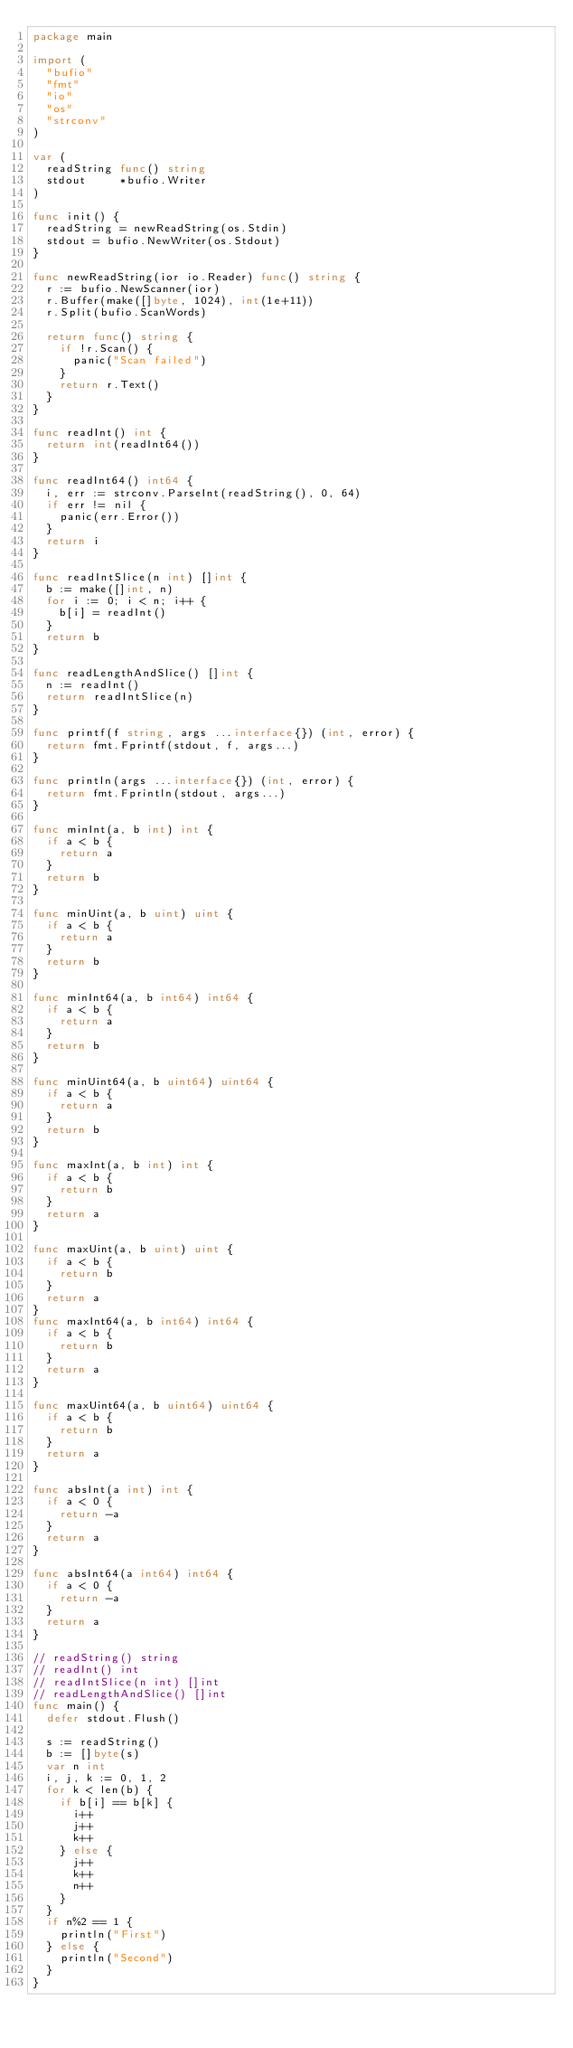<code> <loc_0><loc_0><loc_500><loc_500><_Go_>package main

import (
	"bufio"
	"fmt"
	"io"
	"os"
	"strconv"
)

var (
	readString func() string
	stdout     *bufio.Writer
)

func init() {
	readString = newReadString(os.Stdin)
	stdout = bufio.NewWriter(os.Stdout)
}

func newReadString(ior io.Reader) func() string {
	r := bufio.NewScanner(ior)
	r.Buffer(make([]byte, 1024), int(1e+11))
	r.Split(bufio.ScanWords)

	return func() string {
		if !r.Scan() {
			panic("Scan failed")
		}
		return r.Text()
	}
}

func readInt() int {
	return int(readInt64())
}

func readInt64() int64 {
	i, err := strconv.ParseInt(readString(), 0, 64)
	if err != nil {
		panic(err.Error())
	}
	return i
}

func readIntSlice(n int) []int {
	b := make([]int, n)
	for i := 0; i < n; i++ {
		b[i] = readInt()
	}
	return b
}

func readLengthAndSlice() []int {
	n := readInt()
	return readIntSlice(n)
}

func printf(f string, args ...interface{}) (int, error) {
	return fmt.Fprintf(stdout, f, args...)
}

func println(args ...interface{}) (int, error) {
	return fmt.Fprintln(stdout, args...)
}

func minInt(a, b int) int {
	if a < b {
		return a
	}
	return b
}

func minUint(a, b uint) uint {
	if a < b {
		return a
	}
	return b
}

func minInt64(a, b int64) int64 {
	if a < b {
		return a
	}
	return b
}

func minUint64(a, b uint64) uint64 {
	if a < b {
		return a
	}
	return b
}

func maxInt(a, b int) int {
	if a < b {
		return b
	}
	return a
}

func maxUint(a, b uint) uint {
	if a < b {
		return b
	}
	return a
}
func maxInt64(a, b int64) int64 {
	if a < b {
		return b
	}
	return a
}

func maxUint64(a, b uint64) uint64 {
	if a < b {
		return b
	}
	return a
}

func absInt(a int) int {
	if a < 0 {
		return -a
	}
	return a
}

func absInt64(a int64) int64 {
	if a < 0 {
		return -a
	}
	return a
}

// readString() string
// readInt() int
// readIntSlice(n int) []int
// readLengthAndSlice() []int
func main() {
	defer stdout.Flush()

	s := readString()
	b := []byte(s)
	var n int
	i, j, k := 0, 1, 2
	for k < len(b) {
		if b[i] == b[k] {
			i++
			j++
			k++
		} else {
			j++
			k++
			n++
		}
	}
	if n%2 == 1 {
		println("First")
	} else {
		println("Second")
	}
}
</code> 